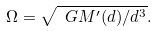Convert formula to latex. <formula><loc_0><loc_0><loc_500><loc_500>\Omega = \sqrt { \ G M ^ { \prime } ( d ) / d ^ { 3 } } .</formula> 